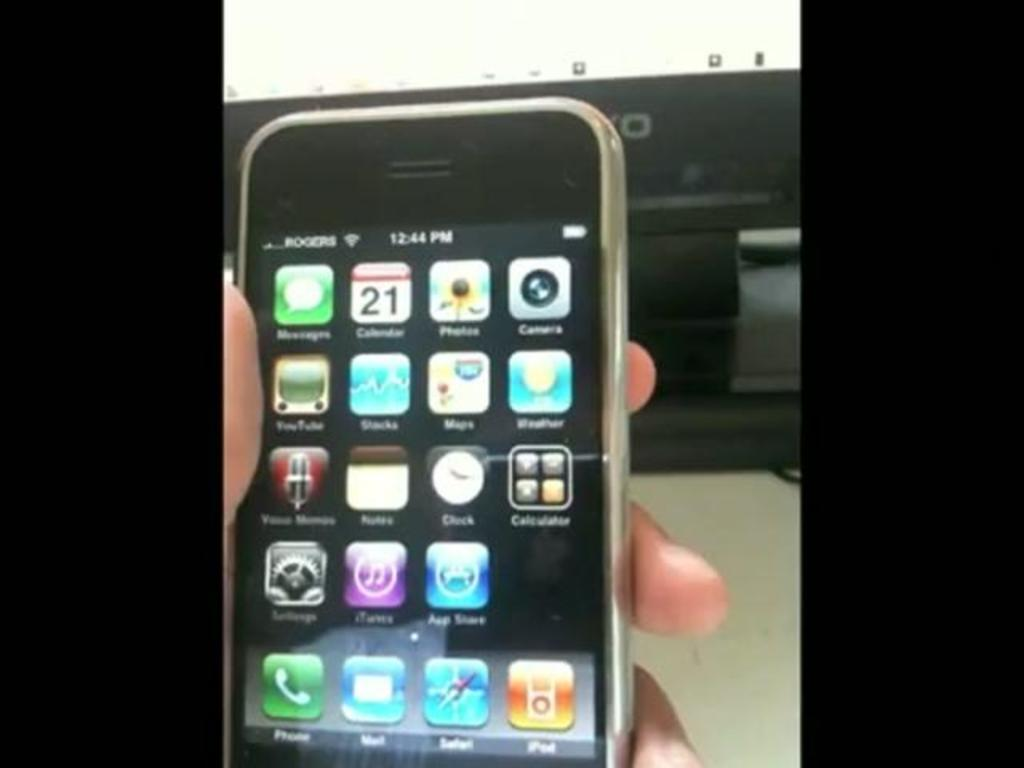Provide a one-sentence caption for the provided image. A person holding a mobile Apple device at 12:44 PM. 